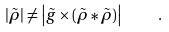<formula> <loc_0><loc_0><loc_500><loc_500>| \tilde { \rho } | \neq \left | \tilde { g } \times ( \tilde { \rho } \ast \tilde { \rho } ) \right | \quad .</formula> 